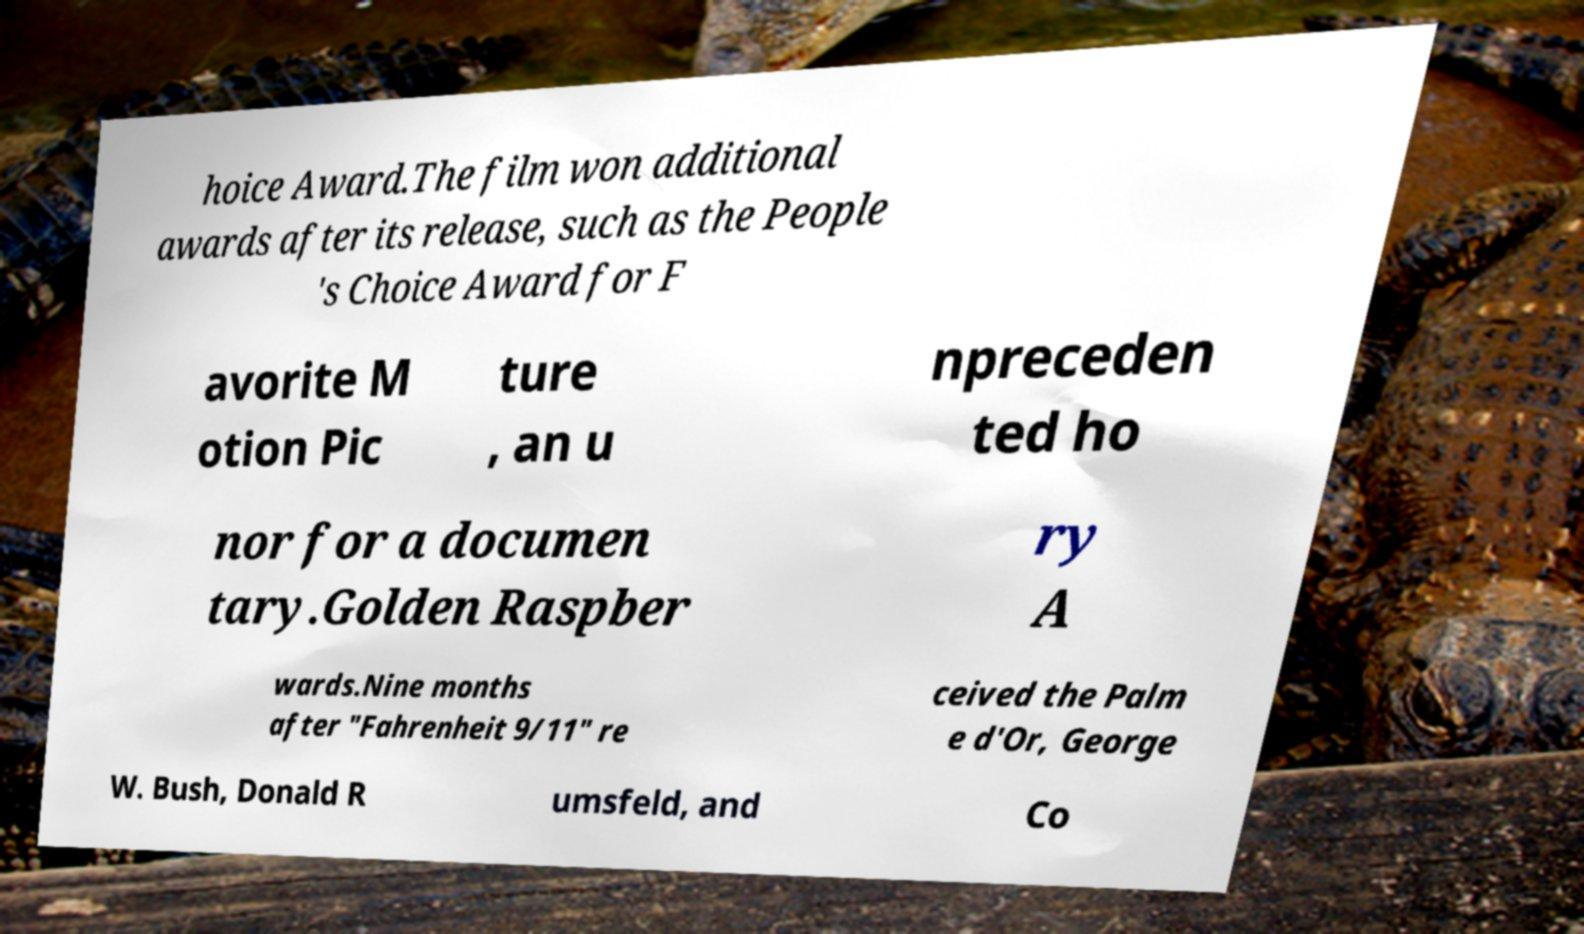Please identify and transcribe the text found in this image. hoice Award.The film won additional awards after its release, such as the People 's Choice Award for F avorite M otion Pic ture , an u npreceden ted ho nor for a documen tary.Golden Raspber ry A wards.Nine months after "Fahrenheit 9/11" re ceived the Palm e d'Or, George W. Bush, Donald R umsfeld, and Co 